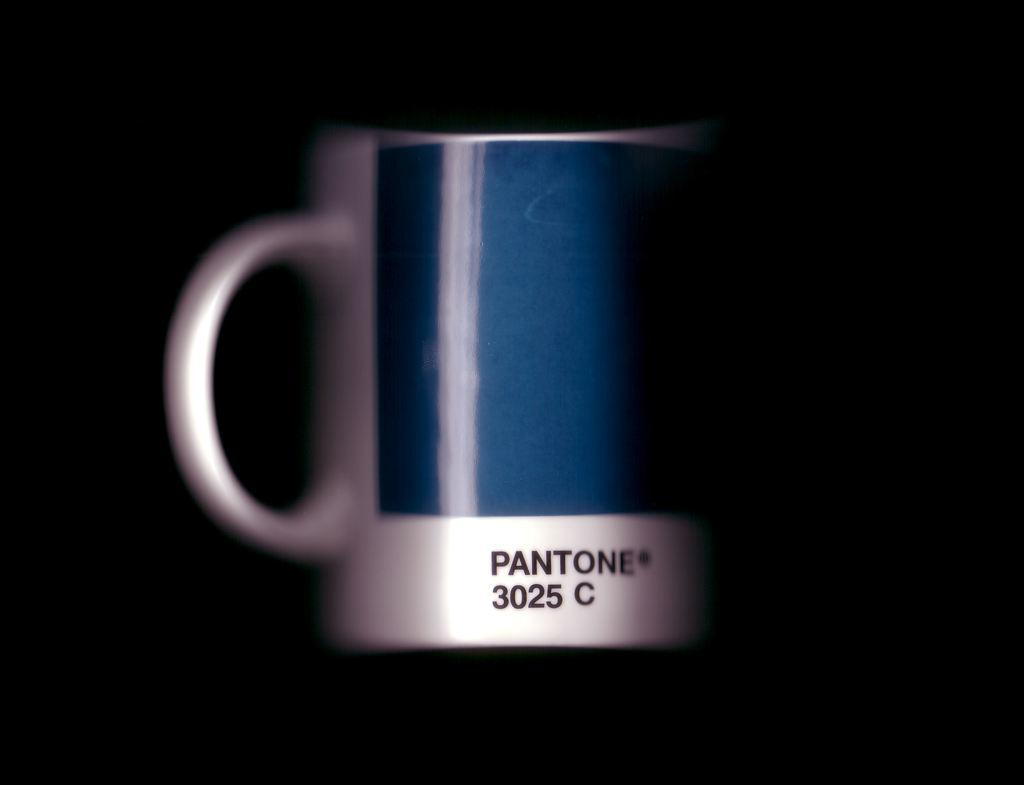What object can be seen in the image? There is a mug in the image. What is written or depicted on the mug? There is text on the mug. How would you describe the overall appearance of the image? The background of the image is dark. What type of mint is growing on the mug in the image? There is no mint growing on the mug in the image; it is a mug with text on it. How does the person wearing the trousers feel about the shock they received in the image? There are no trousers or shocks present in the image; it only features a mug with text on it. 